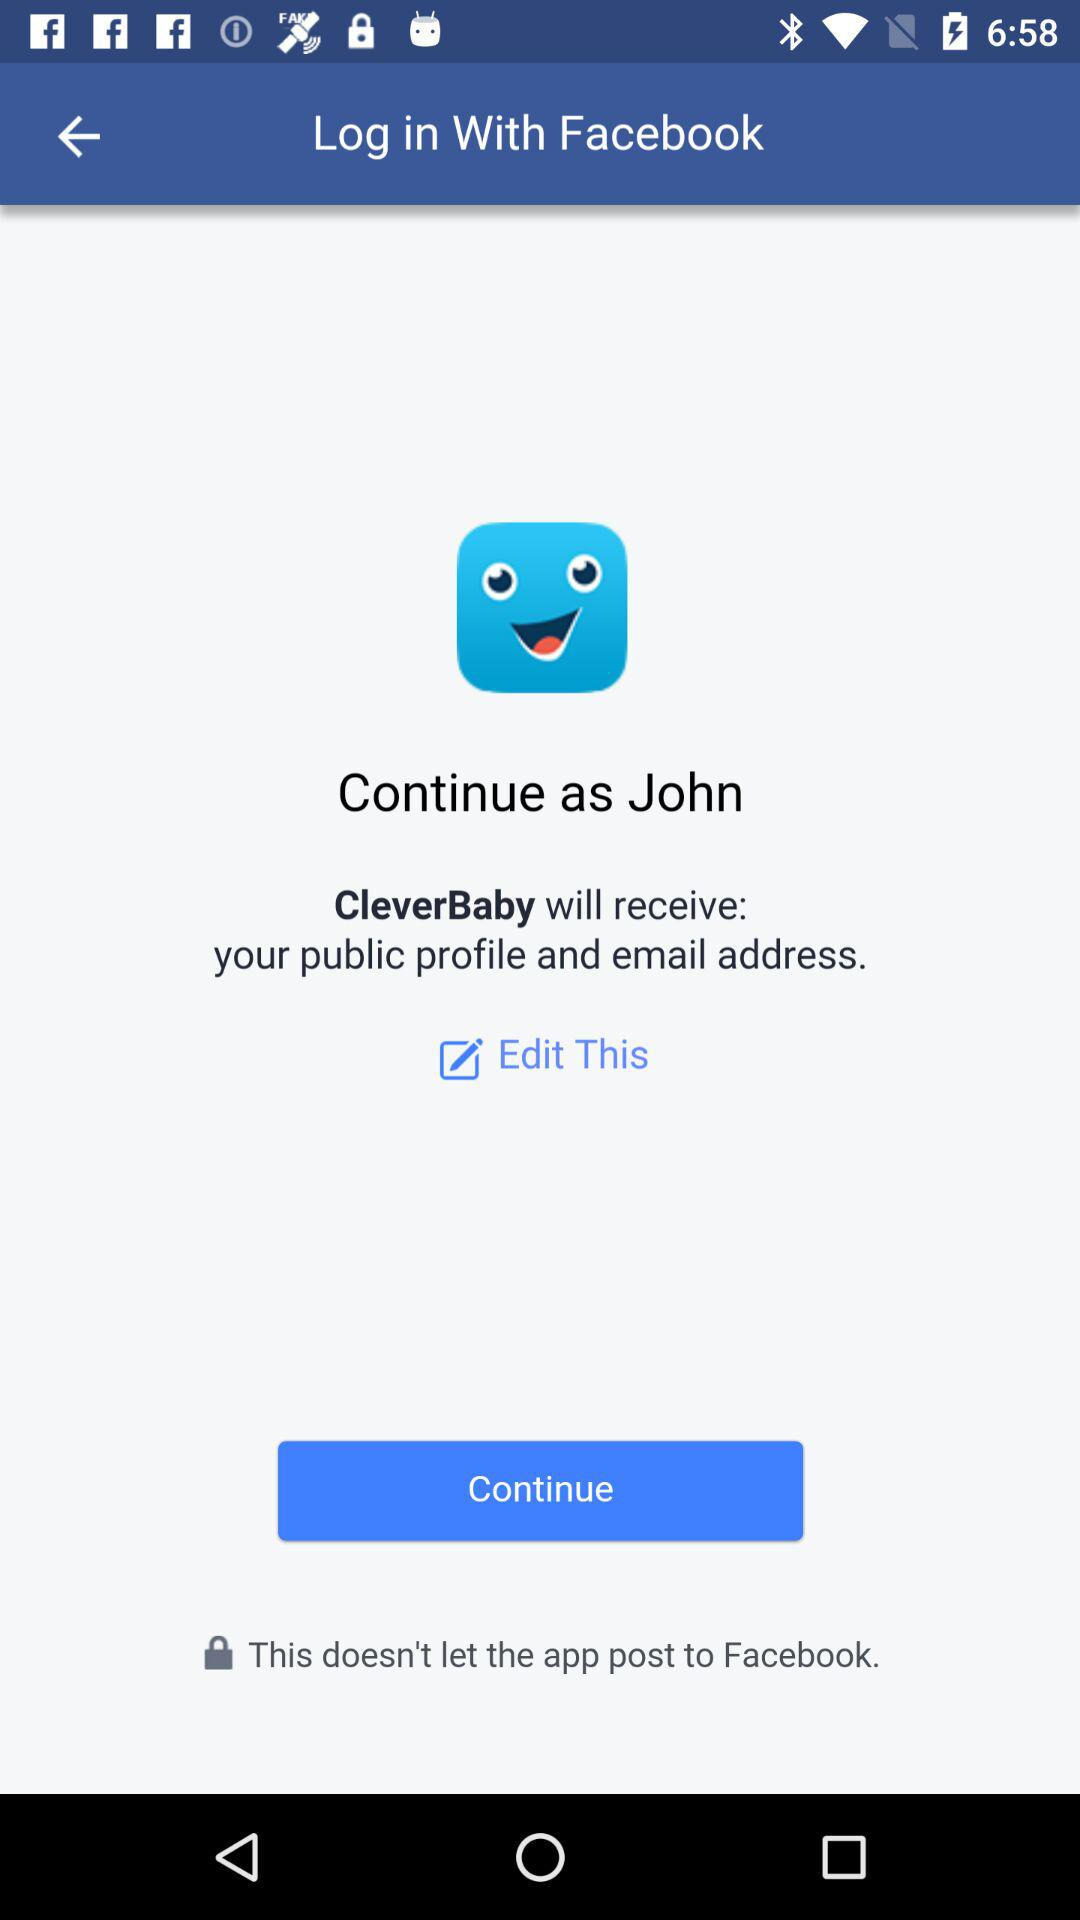What is the user name so that the profile can be continued? The user name is John. 